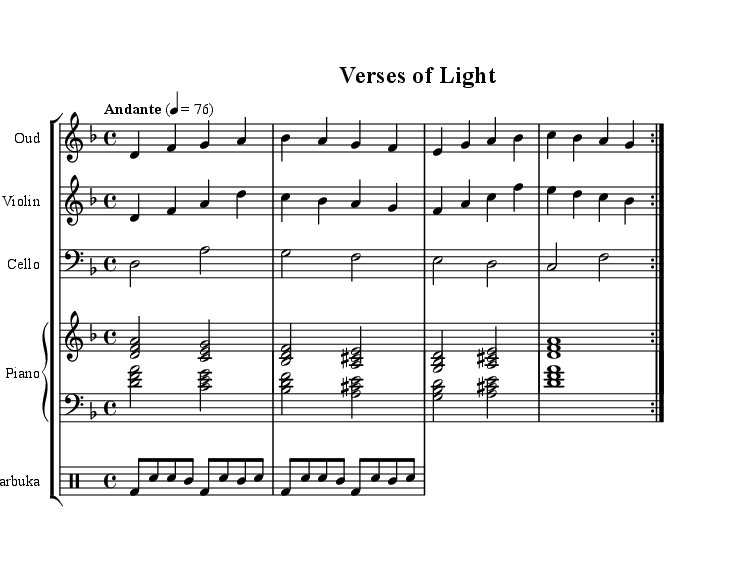What is the key signature of this music? The key signature is indicated by the absence of any sharps or flats in the music. In this case, it is D minor, which has one flat.
Answer: D minor What is the time signature of this piece? The time signature appears at the beginning of the score and is written in the format of a fraction. This piece is marked as 4/4, which indicates four beats per measure.
Answer: 4/4 What is the tempo marking for this piece? The tempo marking is located at the beginning of the score, indicating the speed of the piece. Here it reads "Andante" at a metronome marking of 76 beats per minute.
Answer: Andante 76 How many instruments are being used in this score? By observing the score, we can see five distinct instruments are included: Oud, Violin, Cello, Piano, and Darbuka.
Answer: Five What note duration is primarily used for the Oud part? The Oud part primarily consists of quarter notes, as indicated by the note values throughout the section.
Answer: Quarter notes Which instrument plays the bass clef? The Cello is the only instrument noted to use the bass clef, which is indicated at the beginning of the Cello staff.
Answer: Cello What rhythmic pattern is used in the Darbuka part? The rhythmic pattern is defined using a combination of bass drum (bd), snare (sn), and tom (tomml) notes within the drum part. The Darbuka part showcases a repetitive structure with multiple instances of these patterns.
Answer: Repetitive structure 